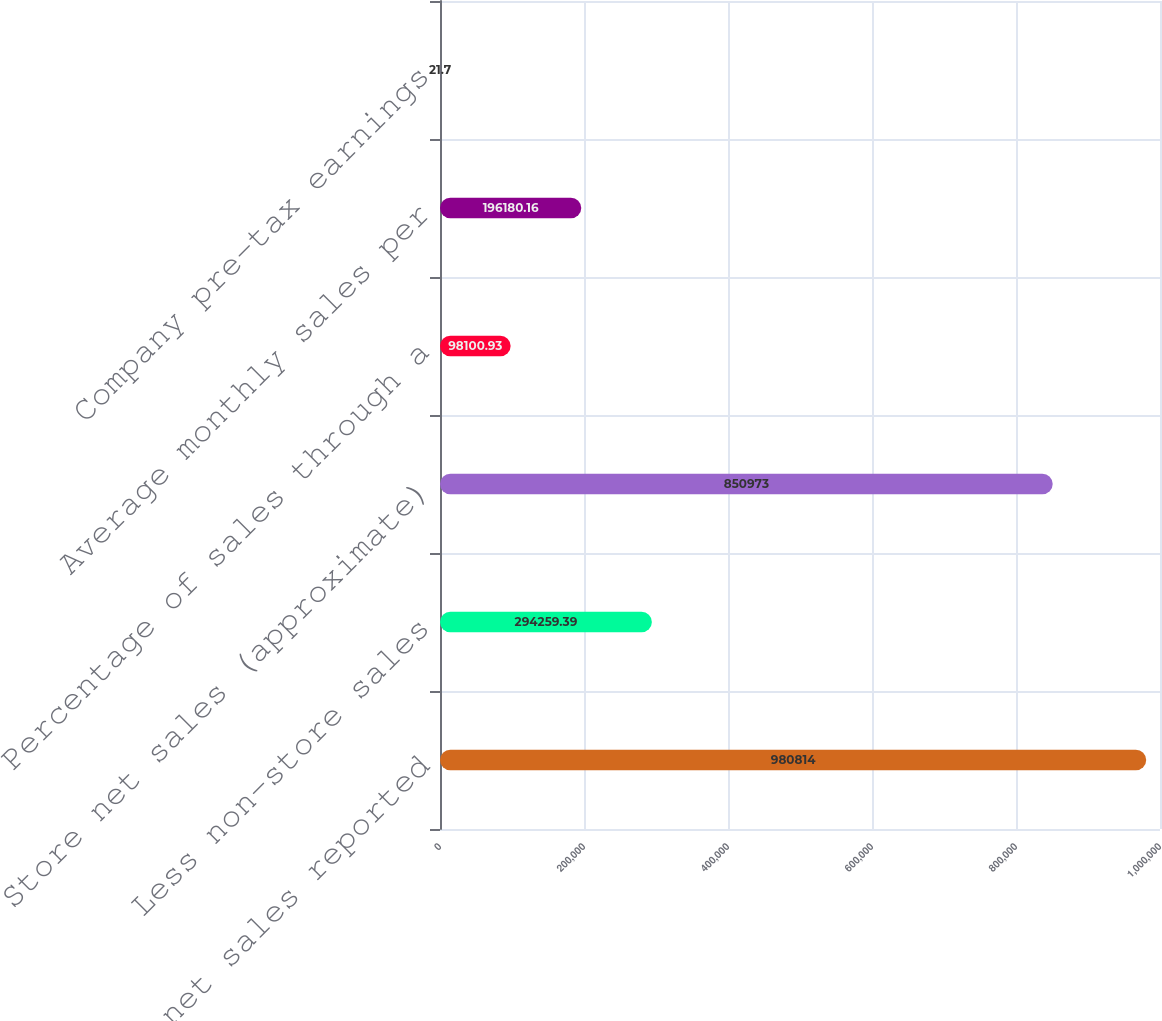Convert chart to OTSL. <chart><loc_0><loc_0><loc_500><loc_500><bar_chart><fcel>Total net sales reported<fcel>Less non-store sales<fcel>Store net sales (approximate)<fcel>Percentage of sales through a<fcel>Average monthly sales per<fcel>Company pre-tax earnings<nl><fcel>980814<fcel>294259<fcel>850973<fcel>98100.9<fcel>196180<fcel>21.7<nl></chart> 